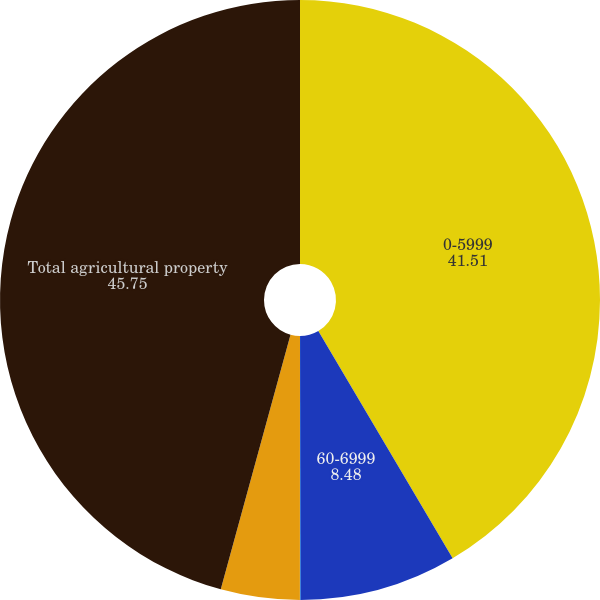Convert chart. <chart><loc_0><loc_0><loc_500><loc_500><pie_chart><fcel>0-5999<fcel>60-6999<fcel>70-7999<fcel>80 or greater<fcel>Total agricultural property<nl><fcel>41.51%<fcel>8.48%<fcel>0.02%<fcel>4.25%<fcel>45.75%<nl></chart> 